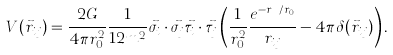Convert formula to latex. <formula><loc_0><loc_0><loc_500><loc_500>V ( { \vec { r } } _ { i j } ) = \frac { 2 G } { 4 \pi r _ { 0 } ^ { 2 } } \frac { 1 } { 1 2 m ^ { 2 } } \vec { \sigma } _ { i } \cdot \vec { \sigma } _ { j } \vec { \tau } _ { i } \cdot \vec { \tau } _ { j } \left ( \frac { 1 } { r _ { 0 } ^ { 2 } } \frac { e ^ { - r _ { i j } / r _ { 0 } } } { r _ { i j } } - 4 \pi \delta ( { \vec { r } } _ { i j } ) \right ) .</formula> 